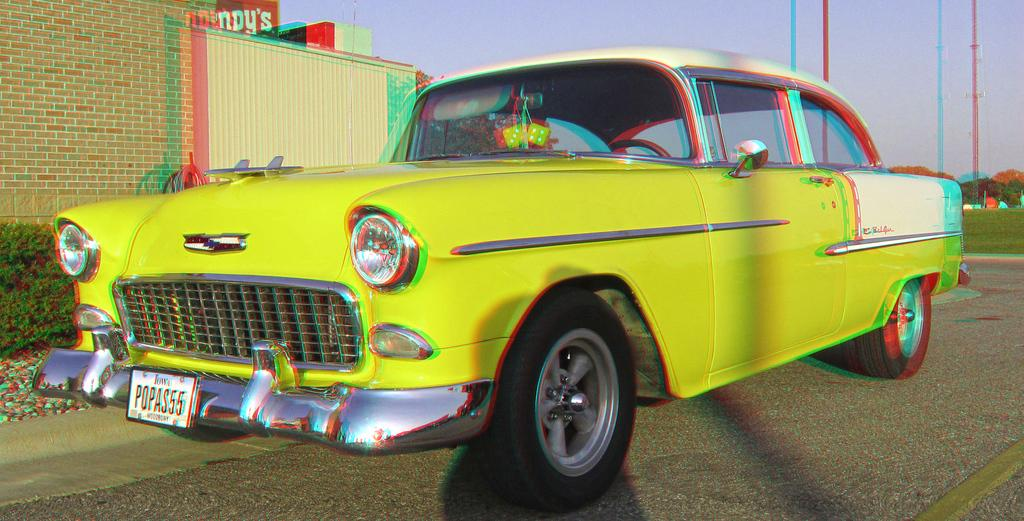<image>
Give a short and clear explanation of the subsequent image. A yellow car is parked by a building with a sign that says Wendy's. 